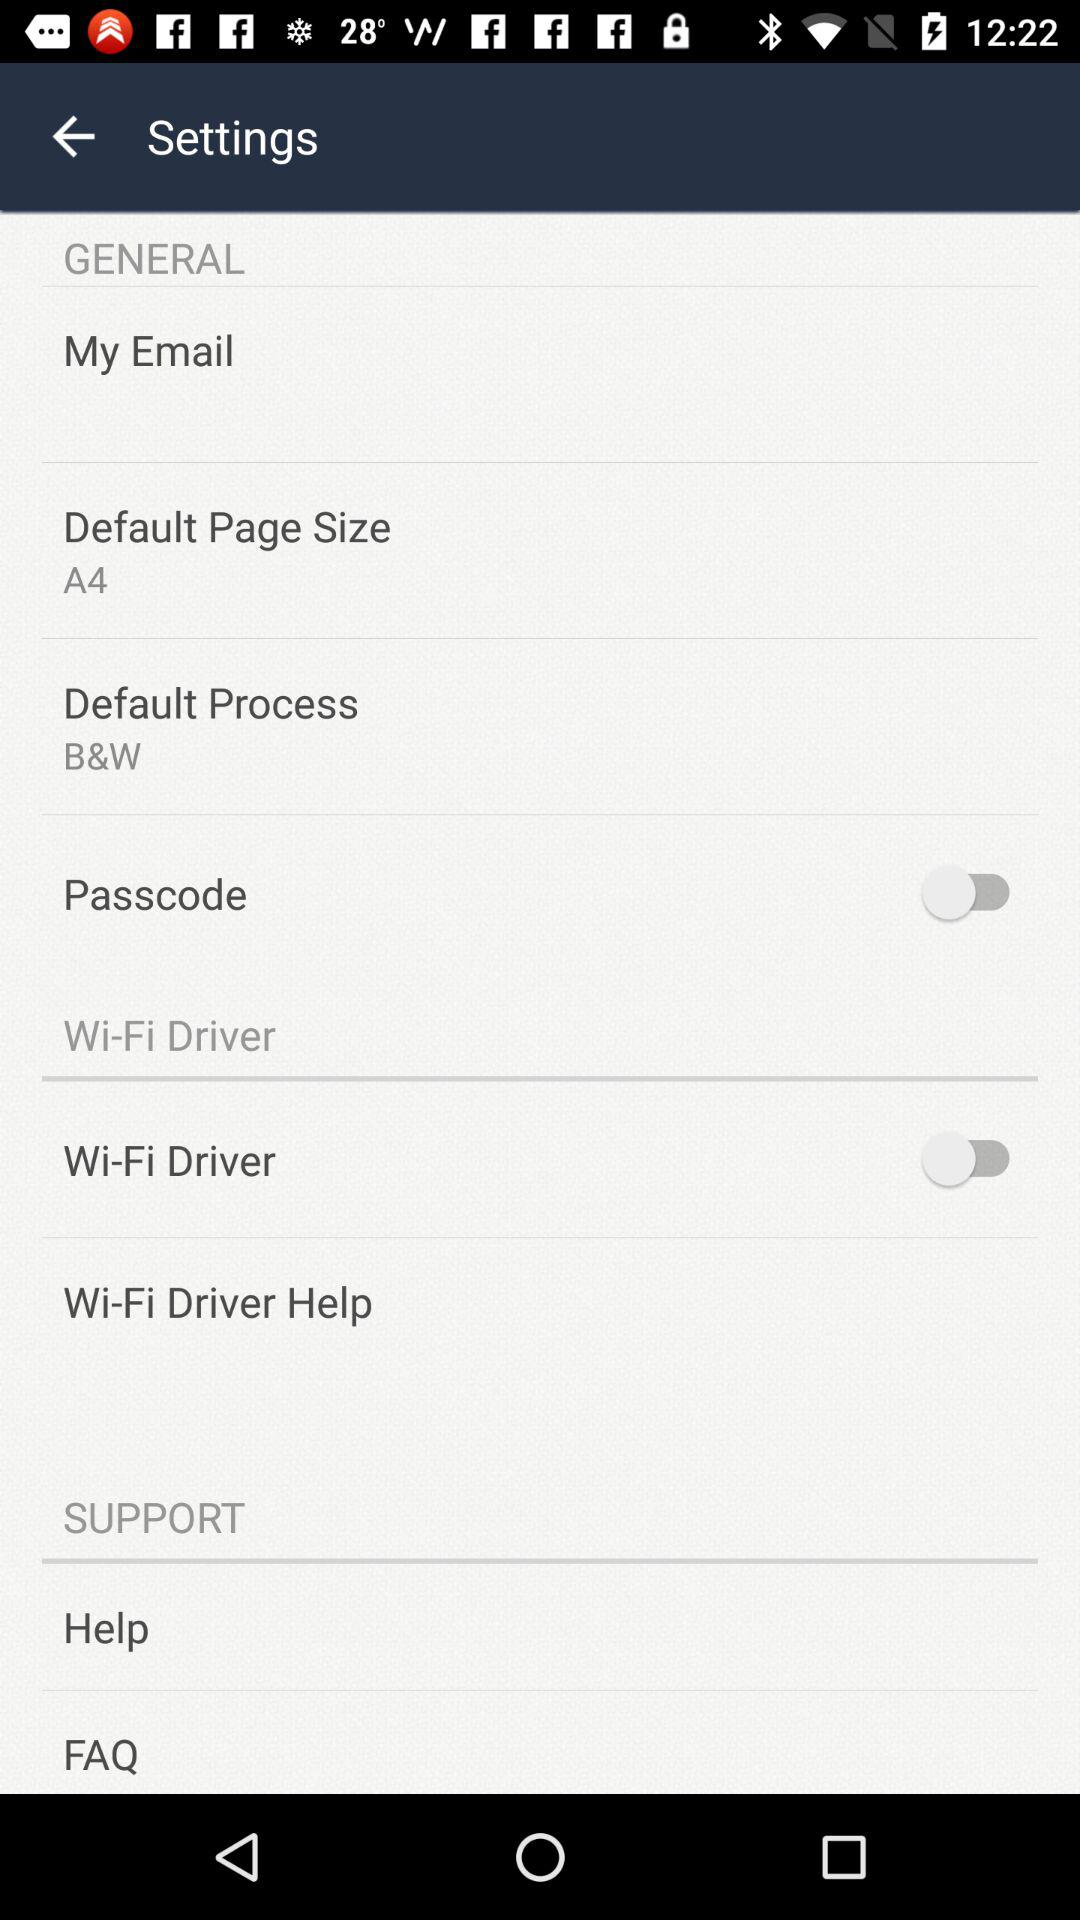How many options are under the Support section?
Answer the question using a single word or phrase. 2 